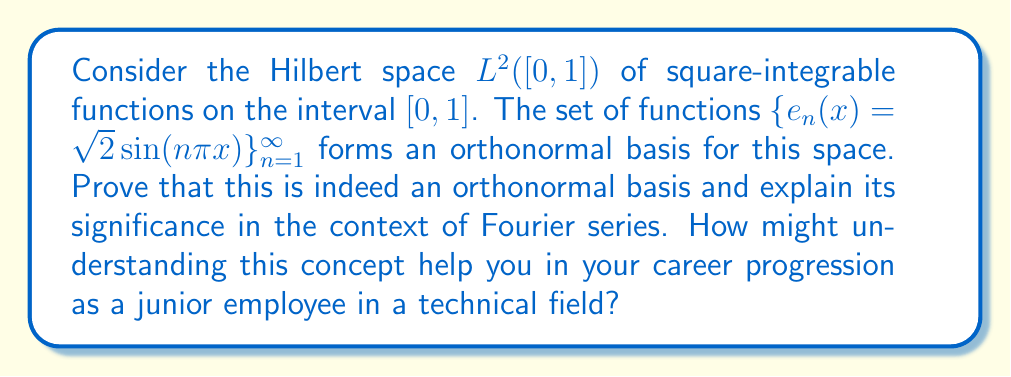Give your solution to this math problem. To prove that $\{e_n(x) = \sqrt{2}\sin(n\pi x)\}_{n=1}^{\infty}$ is an orthonormal basis for $L^2([0,1])$, we need to show two properties:

1. Orthonormality: $\langle e_m, e_n \rangle = \delta_{mn}$ (Kronecker delta)
2. Completeness: The span of $\{e_n\}$ is dense in $L^2([0,1])$

Step 1: Proving orthonormality

We need to show that for any $m,n \in \mathbb{N}$:

$$\langle e_m, e_n \rangle = \int_0^1 e_m(x)e_n(x)dx = \int_0^1 2\sin(m\pi x)\sin(n\pi x)dx = \delta_{mn}$$

Using the trigonometric identity $2\sin A \sin B = \cos(A-B) - \cos(A+B)$, we get:

$$\int_0^1 2\sin(m\pi x)\sin(n\pi x)dx = \int_0^1 [\cos((m-n)\pi x) - \cos((m+n)\pi x)]dx$$

For $m \neq n$, this integral evaluates to 0.
For $m = n$, it evaluates to 1.

Thus, $\langle e_m, e_n \rangle = \delta_{mn}$, proving orthonormality.

Step 2: Proving completeness

To prove completeness, we can use the fact that the set of trigonometric functions is complete in $L^2([0,1])$. This is a fundamental result in Fourier analysis, which states that any square-integrable function on $[0,1]$ can be approximated arbitrarily well by a linear combination of these sine functions.

The significance of this orthonormal basis in the context of Fourier series is profound. It allows us to represent any function $f \in L^2([0,1])$ as an infinite sum:

$$f(x) = \sum_{n=1}^{\infty} c_n e_n(x)$$

where $c_n = \langle f, e_n \rangle$ are the Fourier coefficients.

Understanding this concept can help in career progression by:

1. Developing analytical skills for problem-solving in complex systems.
2. Gaining insights into signal processing and data analysis techniques.
3. Enhancing understanding of mathematical modeling in various scientific and engineering fields.
4. Improving ability to work with abstract concepts, which is valuable in many technical roles.
Answer: The set $\{e_n(x) = \sqrt{2}\sin(n\pi x)\}_{n=1}^{\infty}$ is indeed an orthonormal basis for $L^2([0,1])$. This is proven by showing:

1. Orthonormality: $\langle e_m, e_n \rangle = \delta_{mn}$
2. Completeness: The span of $\{e_n\}$ is dense in $L^2([0,1])$

This basis is significant in Fourier analysis, allowing representation of any $f \in L^2([0,1])$ as $f(x) = \sum_{n=1}^{\infty} c_n e_n(x)$, where $c_n = \langle f, e_n \rangle$ are the Fourier coefficients. 